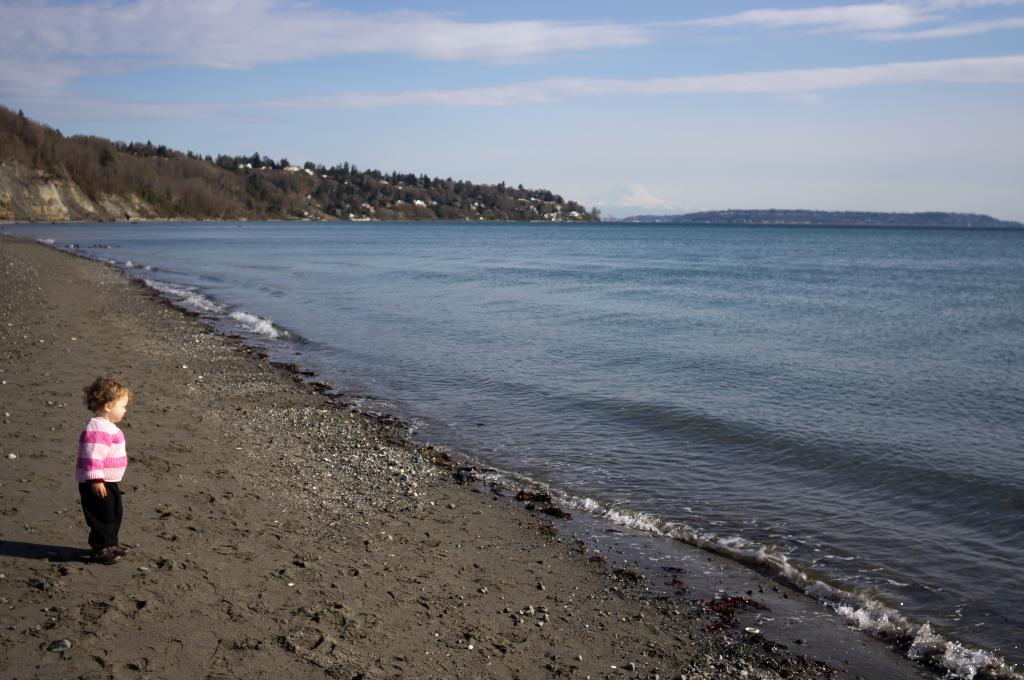What is the child doing in the image? The child is standing on the sea shore. What can be seen on the ground near the child? There are stones visible in the image. What is the large body of water in the image? There is a large water body in the image, which is likely the sea. What is visible on the hills in the background? There is a group of trees on the hills. How would you describe the sky in the image? The sky appears cloudy in the image. What is the child's feeling about the chance of rain in the image? There is no information about the child's feelings or the chance of rain in the image. 